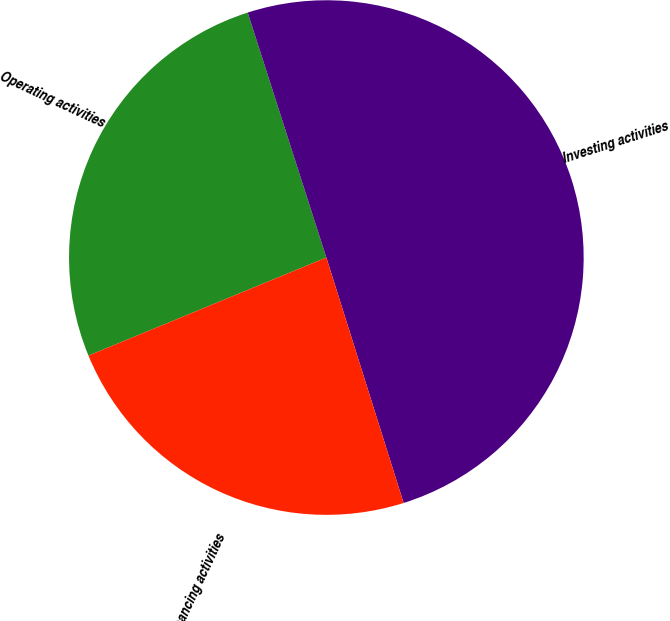<chart> <loc_0><loc_0><loc_500><loc_500><pie_chart><fcel>Operating activities<fcel>Investing activities<fcel>Financing activities<nl><fcel>26.28%<fcel>50.09%<fcel>23.63%<nl></chart> 